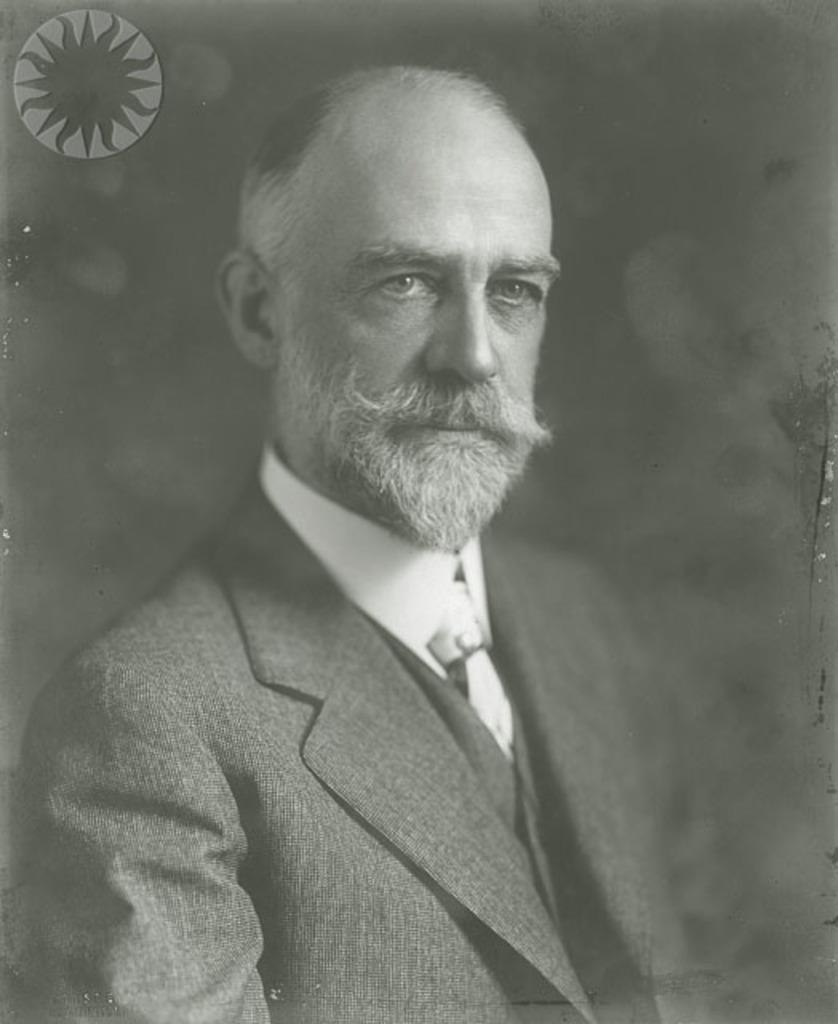What is the main subject of the image? There is a person in the image. What else can be seen in the image besides the person? There is a logo in the image. How would you describe the background of the image? The background of the image is dark. What type of comfort can be seen in the image? There is no specific type of comfort visible in the image. Where is the vacation destination depicted in the image? There is no vacation destination depicted in the image. 